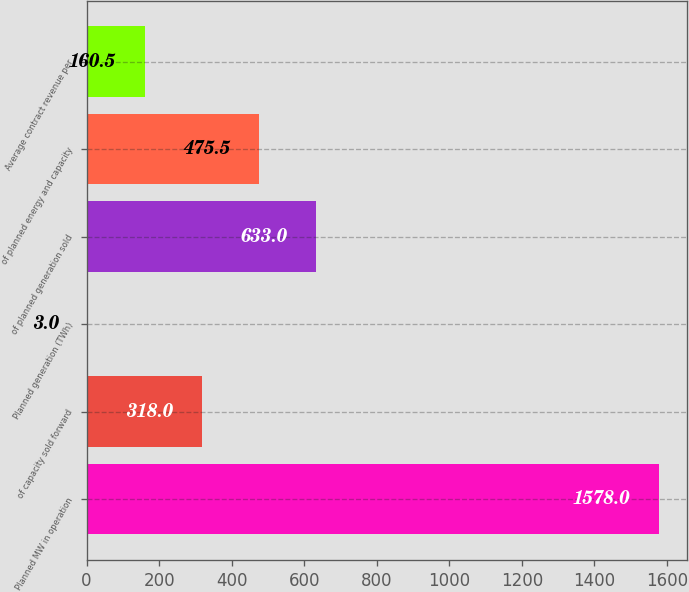Convert chart to OTSL. <chart><loc_0><loc_0><loc_500><loc_500><bar_chart><fcel>Planned MW in operation<fcel>of capacity sold forward<fcel>Planned generation (TWh)<fcel>of planned generation sold<fcel>of planned energy and capacity<fcel>Average contract revenue per<nl><fcel>1578<fcel>318<fcel>3<fcel>633<fcel>475.5<fcel>160.5<nl></chart> 